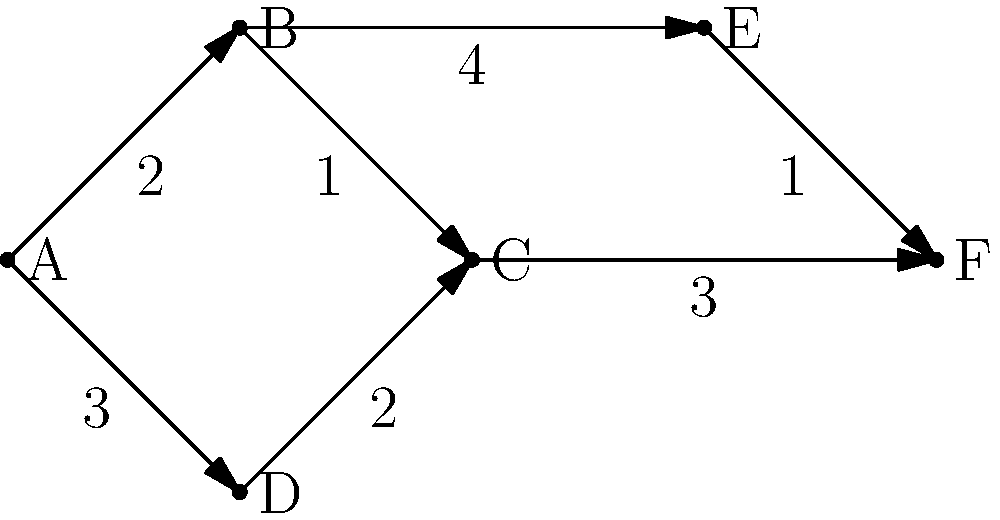As a stamp distribution expert, you're tasked with finding the shortest path to deliver a limited edition stamp from warehouse A to collector F. Given the directed graph where vertices represent locations and edge weights represent delivery times in hours, what is the shortest time (in hours) to deliver the stamp from A to F? To find the shortest path from A to F, we'll use Dijkstra's algorithm:

1) Initialize distances: A(0), B(∞), C(∞), D(∞), E(∞), F(∞)
2) Start from A:
   - Update B: min(∞, 0+2) = 2
   - Update D: min(∞, 0+3) = 3
3) Select B (shortest unvisited):
   - Update C: min(∞, 2+1) = 3
   - Update E: min(∞, 2+4) = 6
4) Select C (shortest unvisited):
   - Update F: min(∞, 3+3) = 6
5) Select D:
   - Update C: min(3, 3+2) = 3 (no change)
6) Select E:
   - Update F: min(6, 6+1) = 6 (no change)
7) F is reached, algorithm terminates.

The shortest path is A → B → C → F, with a total time of 6 hours.
Answer: 6 hours 